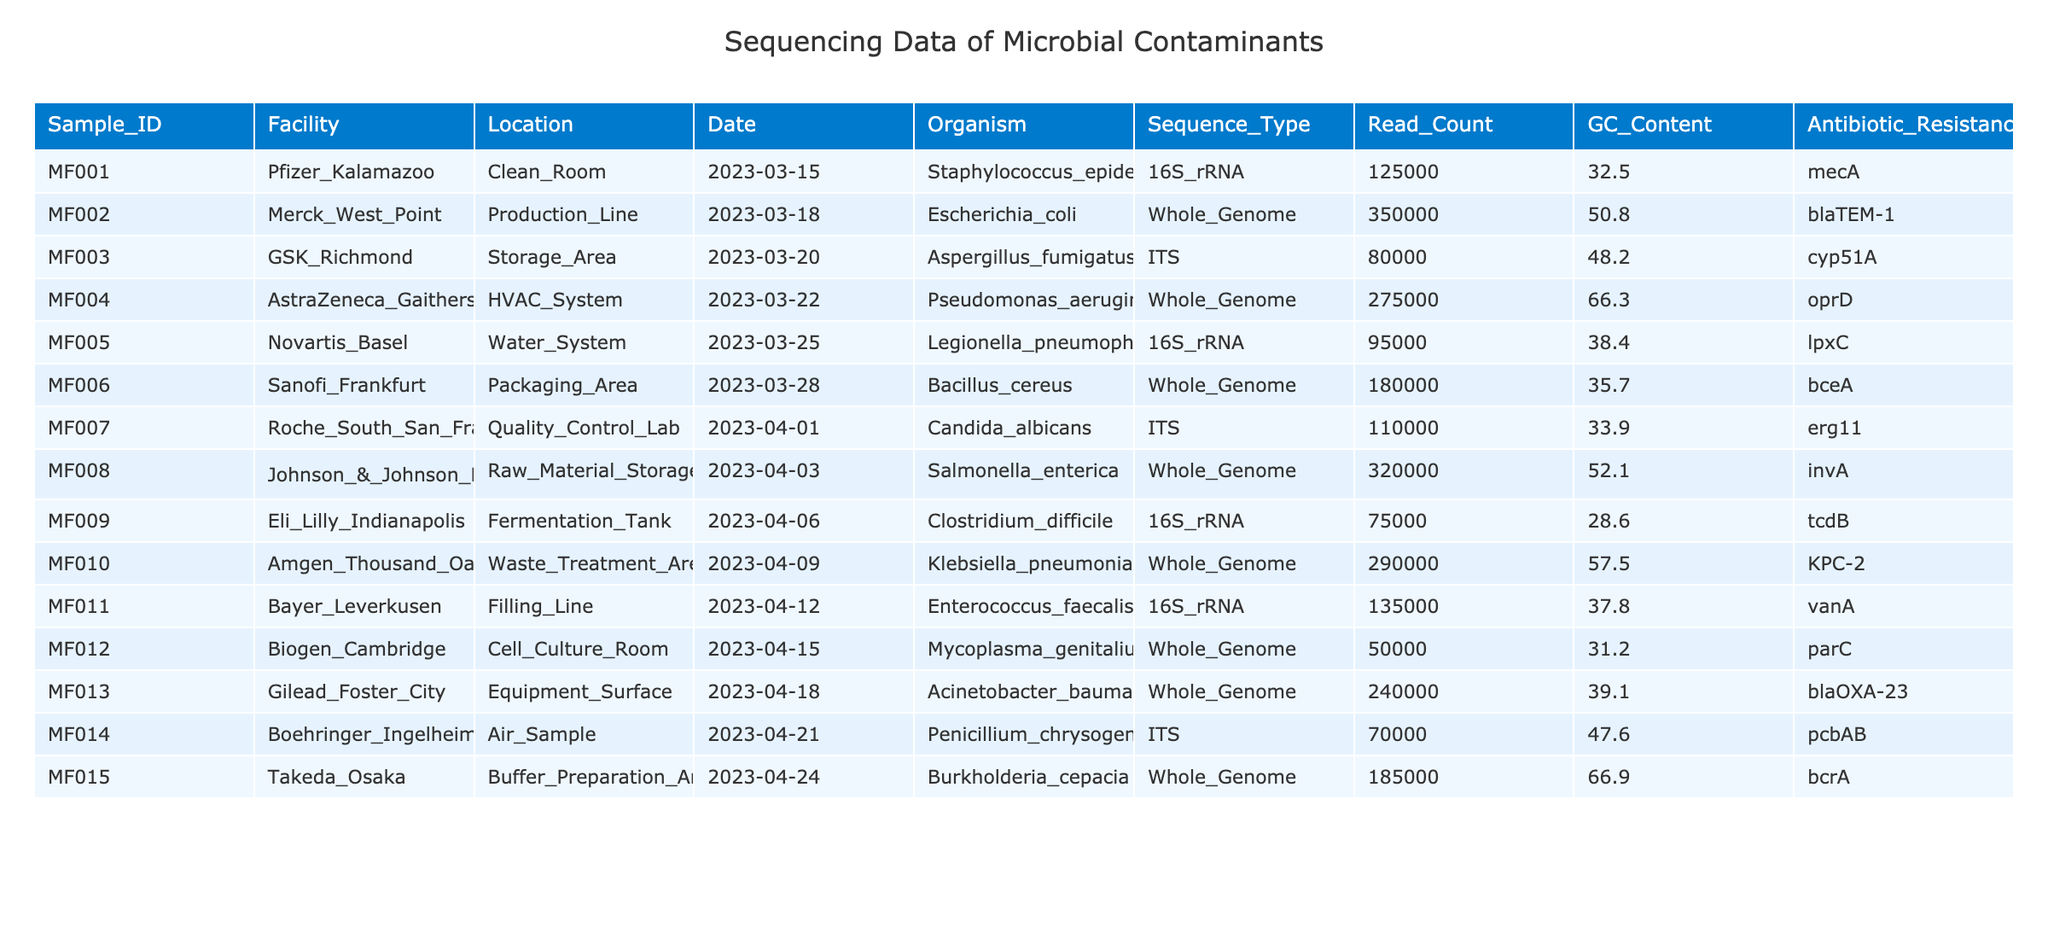What is the organism found in the Clean Room at Pfizer Kalamazoo? The table lists the Clean Room under Pfizer Kalamazoo and shows that the organism present is Staphylococcus epidermidis.
Answer: Staphylococcus epidermidis Which location had the highest read count for sequencing data? Looking at the read counts in the table, the highest read count is 350,000 from the Production Line at Merck West Point.
Answer: Production Line at Merck West Point How many facilities show the presence of antibiotic resistance genes? By examining the antibiotic resistance gene column, there are 10 out of 15 facilities with resistance genes listed.
Answer: 10 What is the average GC content of organisms sequenced in Whole Genome studies? The GC content values for Whole Genome organisms are 50.8, 66.3, 52.1, 57.5, 31.2, 39.1, 66.9, adding them gives 364.9, and dividing by 8 (the number of Whole Genome samples) results in an average GC content of 45.61.
Answer: 45.61 Is there any organism found in the Packaging Area that has antibiotic resistance genes? The table shows that the organism in the Packaging Area is Bacillus cereus, which has the antibiotic resistance gene bceA noted. Therefore, the answer is yes.
Answer: Yes Which facility has the lowest Read Count, and what is the corresponding organism? Checking the Read Count values, the lowest is 50,000 from Biogen Cambridge, where the organism is Mycoplasma genitalium.
Answer: Biogen Cambridge, Mycoplasma genitalium Are there any organisms detected in the Water System with antibiotic resistance genes? In the Water System, the organism Legionella pneumophila has the antibiotic resistance gene lpxC listed in the table, indicating the presence of antibiotic resistance.
Answer: Yes What is the difference in Read Count between the organism found in the Fermentation Tank and the one in the Waste Treatment Area? The Read Count for the organism in the Fermentation Tank (75,000) and the Waste Treatment Area (290,000) can be calculated. The difference is 290,000 - 75,000 = 215,000.
Answer: 215,000 Which organism from the HVAC System had the highest GC content? The HVAC System contains Pseudomonas aeruginosa with a GC content of 66.3, which is higher compared to the other organisms in the same category.
Answer: Pseudomonas aeruginosa, 66.3 If only considering the organisms with ITS sequencing type, what is the total Read Count? From the data, the organisms with ITS sequencing types are Aspergillus fumigatus (80,000), Candida albicans (110,000), and Penicillium chrysogenum (70,000). The total is 80,000 + 110,000 + 70,000 = 260,000.
Answer: 260,000 